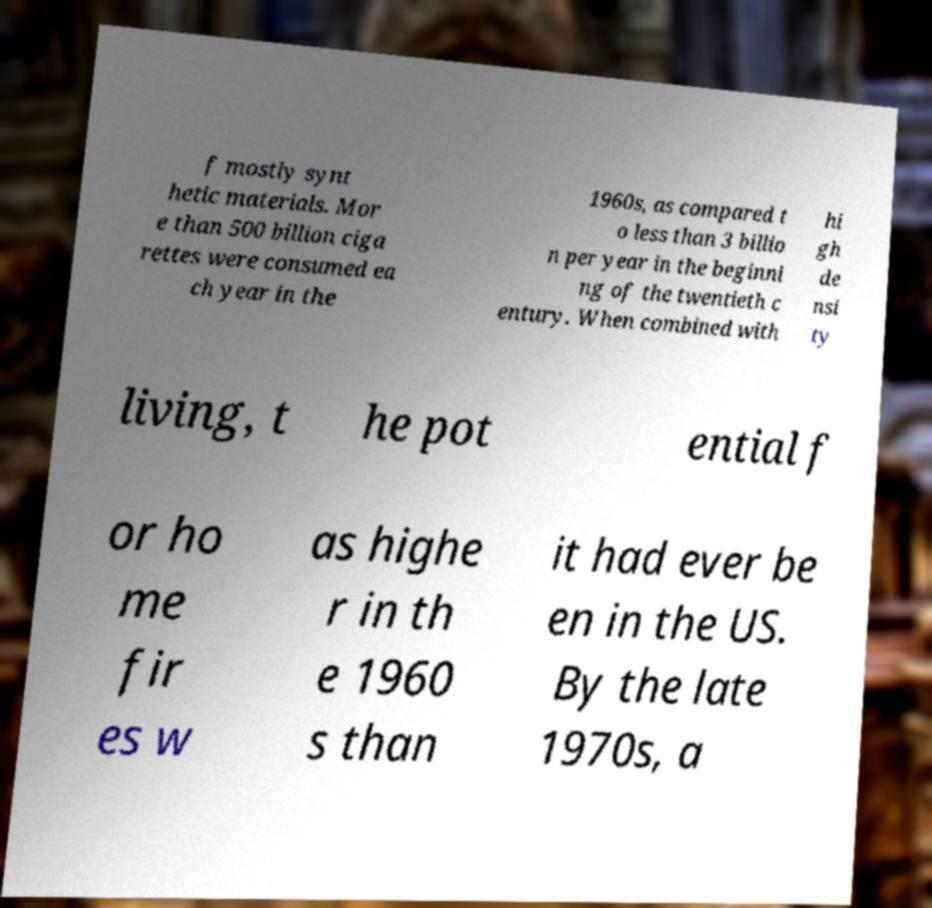What messages or text are displayed in this image? I need them in a readable, typed format. f mostly synt hetic materials. Mor e than 500 billion ciga rettes were consumed ea ch year in the 1960s, as compared t o less than 3 billio n per year in the beginni ng of the twentieth c entury. When combined with hi gh de nsi ty living, t he pot ential f or ho me fir es w as highe r in th e 1960 s than it had ever be en in the US. By the late 1970s, a 